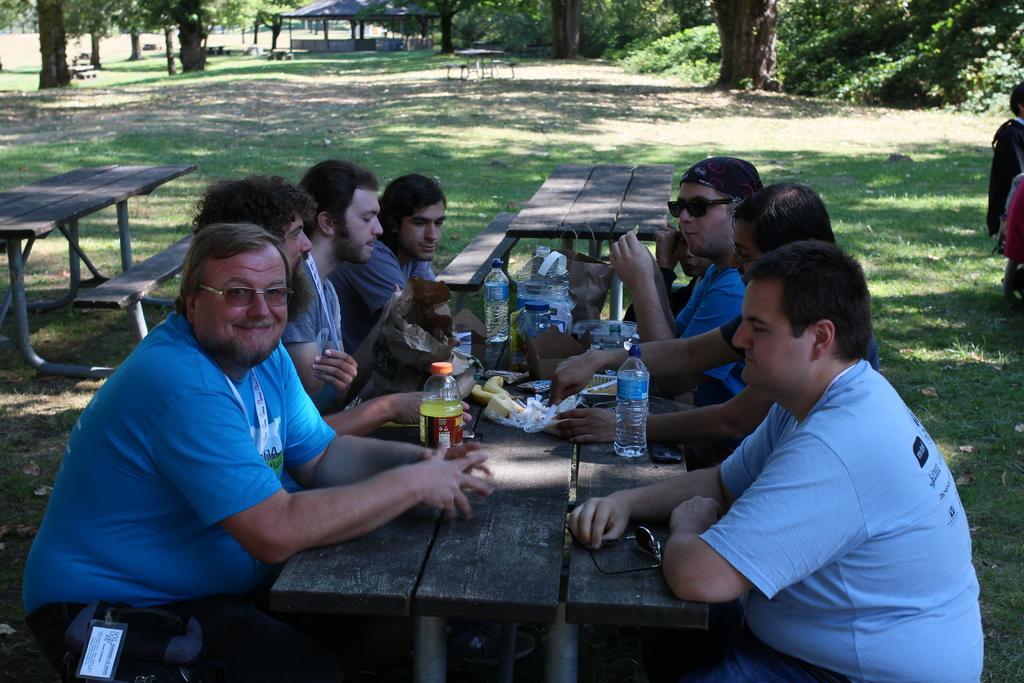Please provide a concise description of this image. This image has a group of people surrounded by a table. Person at the left side is wearing goggles and blue shirt. On table there are bottles, food on it. Back Side to them there are three benches. At the top of the image there are few trees and shed. At right side there are two persons. Middle of the image is having a grassy land. 